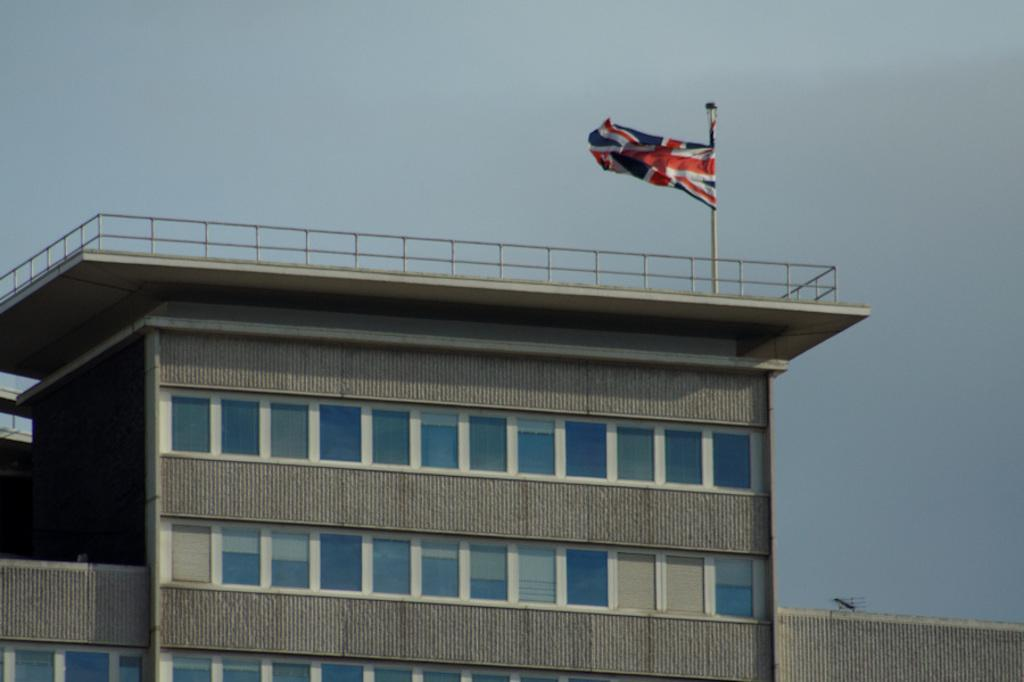What structure is the main subject of the image? There is a building in the image. Where is the building located in relation to the image? The building is in the front of the image. What is on top of the building? There is a flag on top of the building. What type of channel can be seen running through the building in the image? There is no channel visible running through the building in the image. Are there any tomatoes growing on the building in the image? There are no tomatoes present on the building in the image. Is there a birthday celebration happening in the building in the image? There is no indication of a birthday celebration happening in the building in the image. 